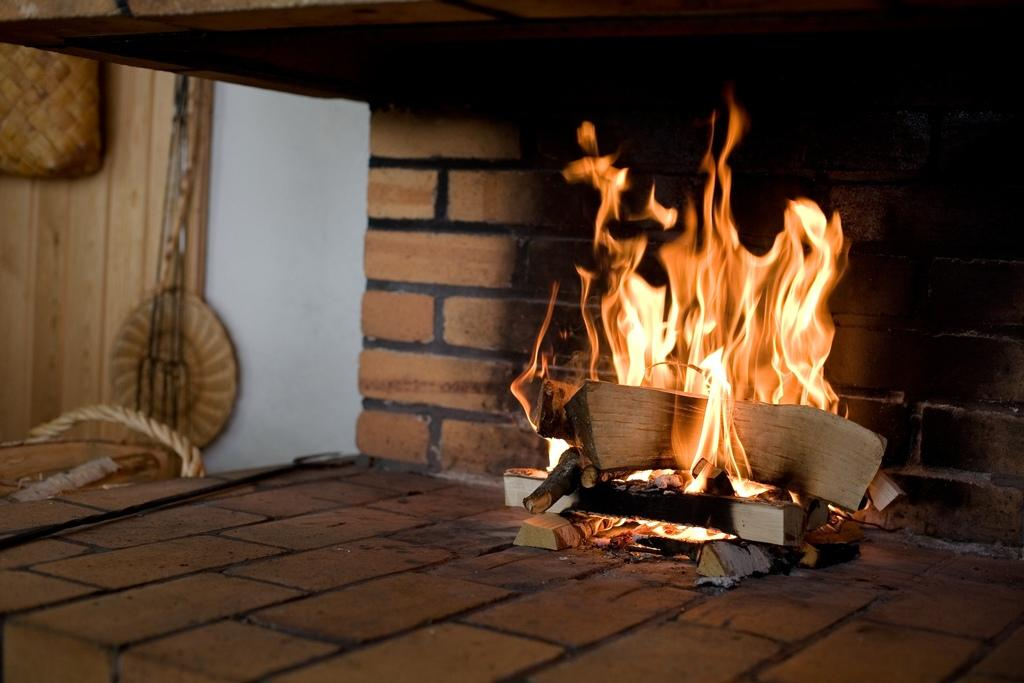What is burning in the image? There are wooden pieces burning in the image. What is the primary source of light in the image? There is fire in the image. What can be seen in the background of the image? There is a brick wall in the background of the image. What is located on the left side of the image? There is a rope on the left side of the image, as well as other objects. How much money can be seen floating in the waves in the image? There are no waves or money present in the image; it features wooden pieces burning and a brick wall in the background. What type of screw is visible in the image? There is no screw present in the image. 